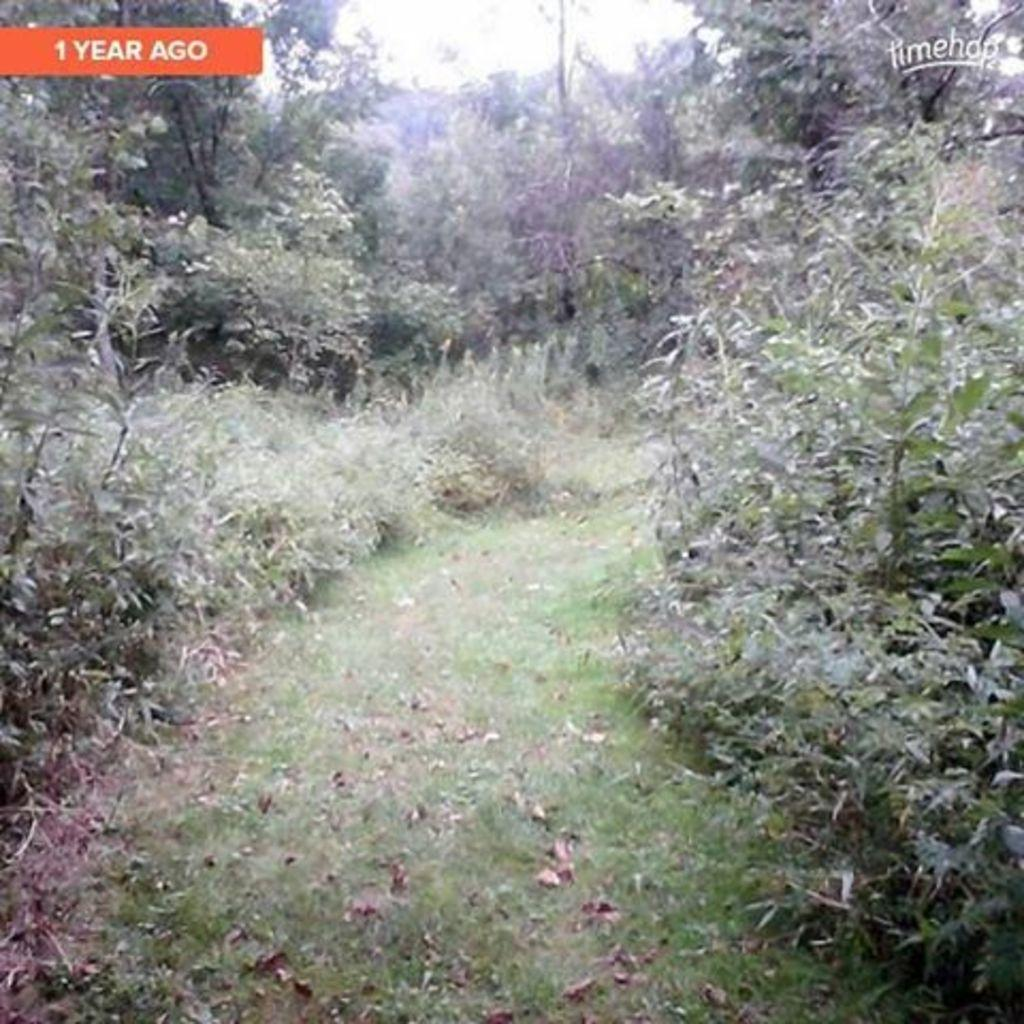What type of vegetation can be seen in the image? There are plants and trees visible in the image. What type of ground cover is present in the image? There is grass visible in the image. What is visible at the top of the image? The sky is visible at the top of the image. Are there any words or letters in the image? Yes, there is text in the image. How many slaves are visible in the image? There are no slaves present in the image. What type of stretching exercise can be seen being performed in the image? There are no stretching exercises or people performing them in the image. 